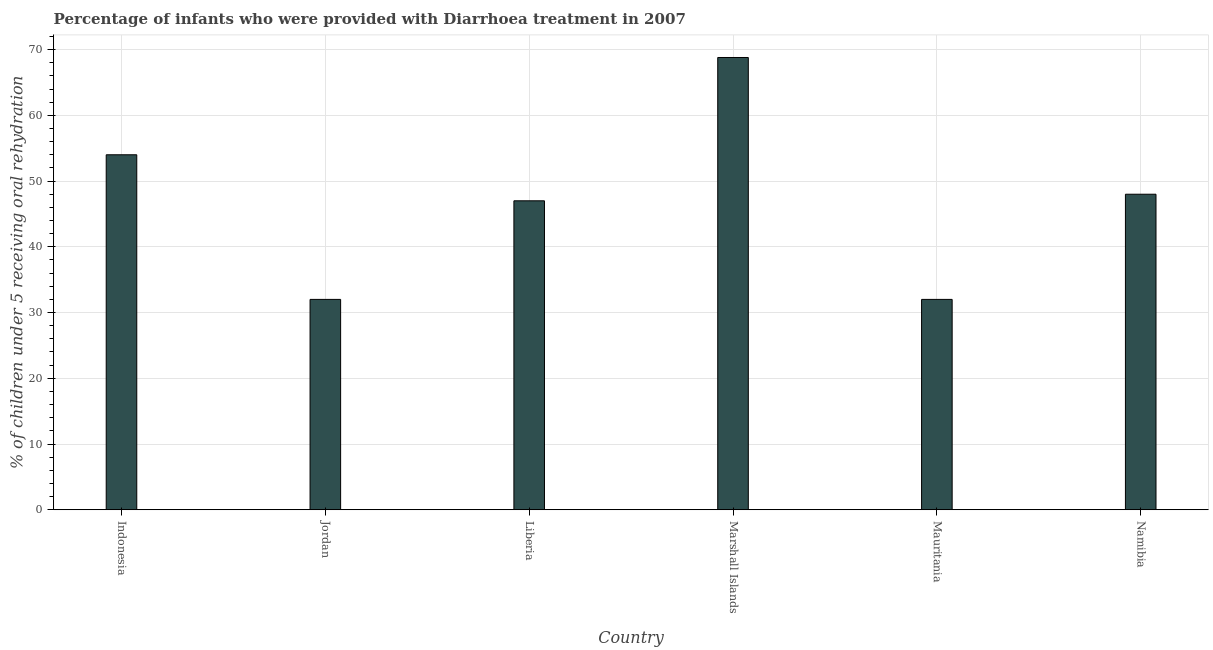Does the graph contain any zero values?
Ensure brevity in your answer.  No. What is the title of the graph?
Offer a terse response. Percentage of infants who were provided with Diarrhoea treatment in 2007. What is the label or title of the X-axis?
Provide a short and direct response. Country. What is the label or title of the Y-axis?
Your response must be concise. % of children under 5 receiving oral rehydration. Across all countries, what is the maximum percentage of children who were provided with treatment diarrhoea?
Offer a very short reply. 68.8. In which country was the percentage of children who were provided with treatment diarrhoea maximum?
Your answer should be compact. Marshall Islands. In which country was the percentage of children who were provided with treatment diarrhoea minimum?
Provide a succinct answer. Jordan. What is the sum of the percentage of children who were provided with treatment diarrhoea?
Offer a terse response. 281.8. What is the difference between the percentage of children who were provided with treatment diarrhoea in Liberia and Namibia?
Ensure brevity in your answer.  -1. What is the average percentage of children who were provided with treatment diarrhoea per country?
Your answer should be compact. 46.97. What is the median percentage of children who were provided with treatment diarrhoea?
Your answer should be compact. 47.5. What is the ratio of the percentage of children who were provided with treatment diarrhoea in Mauritania to that in Namibia?
Provide a succinct answer. 0.67. Is the percentage of children who were provided with treatment diarrhoea in Liberia less than that in Namibia?
Keep it short and to the point. Yes. What is the difference between the highest and the second highest percentage of children who were provided with treatment diarrhoea?
Your response must be concise. 14.8. Is the sum of the percentage of children who were provided with treatment diarrhoea in Indonesia and Jordan greater than the maximum percentage of children who were provided with treatment diarrhoea across all countries?
Make the answer very short. Yes. What is the difference between the highest and the lowest percentage of children who were provided with treatment diarrhoea?
Keep it short and to the point. 36.8. How many bars are there?
Your answer should be very brief. 6. Are the values on the major ticks of Y-axis written in scientific E-notation?
Ensure brevity in your answer.  No. What is the % of children under 5 receiving oral rehydration of Marshall Islands?
Ensure brevity in your answer.  68.8. What is the % of children under 5 receiving oral rehydration in Mauritania?
Provide a short and direct response. 32. What is the difference between the % of children under 5 receiving oral rehydration in Indonesia and Liberia?
Make the answer very short. 7. What is the difference between the % of children under 5 receiving oral rehydration in Indonesia and Marshall Islands?
Offer a very short reply. -14.8. What is the difference between the % of children under 5 receiving oral rehydration in Indonesia and Mauritania?
Provide a short and direct response. 22. What is the difference between the % of children under 5 receiving oral rehydration in Jordan and Liberia?
Your answer should be very brief. -15. What is the difference between the % of children under 5 receiving oral rehydration in Jordan and Marshall Islands?
Make the answer very short. -36.8. What is the difference between the % of children under 5 receiving oral rehydration in Jordan and Mauritania?
Your answer should be compact. 0. What is the difference between the % of children under 5 receiving oral rehydration in Jordan and Namibia?
Your answer should be very brief. -16. What is the difference between the % of children under 5 receiving oral rehydration in Liberia and Marshall Islands?
Your answer should be compact. -21.8. What is the difference between the % of children under 5 receiving oral rehydration in Liberia and Mauritania?
Your answer should be very brief. 15. What is the difference between the % of children under 5 receiving oral rehydration in Liberia and Namibia?
Your answer should be very brief. -1. What is the difference between the % of children under 5 receiving oral rehydration in Marshall Islands and Mauritania?
Offer a very short reply. 36.8. What is the difference between the % of children under 5 receiving oral rehydration in Marshall Islands and Namibia?
Offer a very short reply. 20.8. What is the difference between the % of children under 5 receiving oral rehydration in Mauritania and Namibia?
Your response must be concise. -16. What is the ratio of the % of children under 5 receiving oral rehydration in Indonesia to that in Jordan?
Keep it short and to the point. 1.69. What is the ratio of the % of children under 5 receiving oral rehydration in Indonesia to that in Liberia?
Your response must be concise. 1.15. What is the ratio of the % of children under 5 receiving oral rehydration in Indonesia to that in Marshall Islands?
Your response must be concise. 0.79. What is the ratio of the % of children under 5 receiving oral rehydration in Indonesia to that in Mauritania?
Your answer should be compact. 1.69. What is the ratio of the % of children under 5 receiving oral rehydration in Jordan to that in Liberia?
Your answer should be very brief. 0.68. What is the ratio of the % of children under 5 receiving oral rehydration in Jordan to that in Marshall Islands?
Ensure brevity in your answer.  0.47. What is the ratio of the % of children under 5 receiving oral rehydration in Jordan to that in Namibia?
Your answer should be compact. 0.67. What is the ratio of the % of children under 5 receiving oral rehydration in Liberia to that in Marshall Islands?
Offer a very short reply. 0.68. What is the ratio of the % of children under 5 receiving oral rehydration in Liberia to that in Mauritania?
Your answer should be compact. 1.47. What is the ratio of the % of children under 5 receiving oral rehydration in Marshall Islands to that in Mauritania?
Your answer should be very brief. 2.15. What is the ratio of the % of children under 5 receiving oral rehydration in Marshall Islands to that in Namibia?
Give a very brief answer. 1.43. What is the ratio of the % of children under 5 receiving oral rehydration in Mauritania to that in Namibia?
Provide a short and direct response. 0.67. 